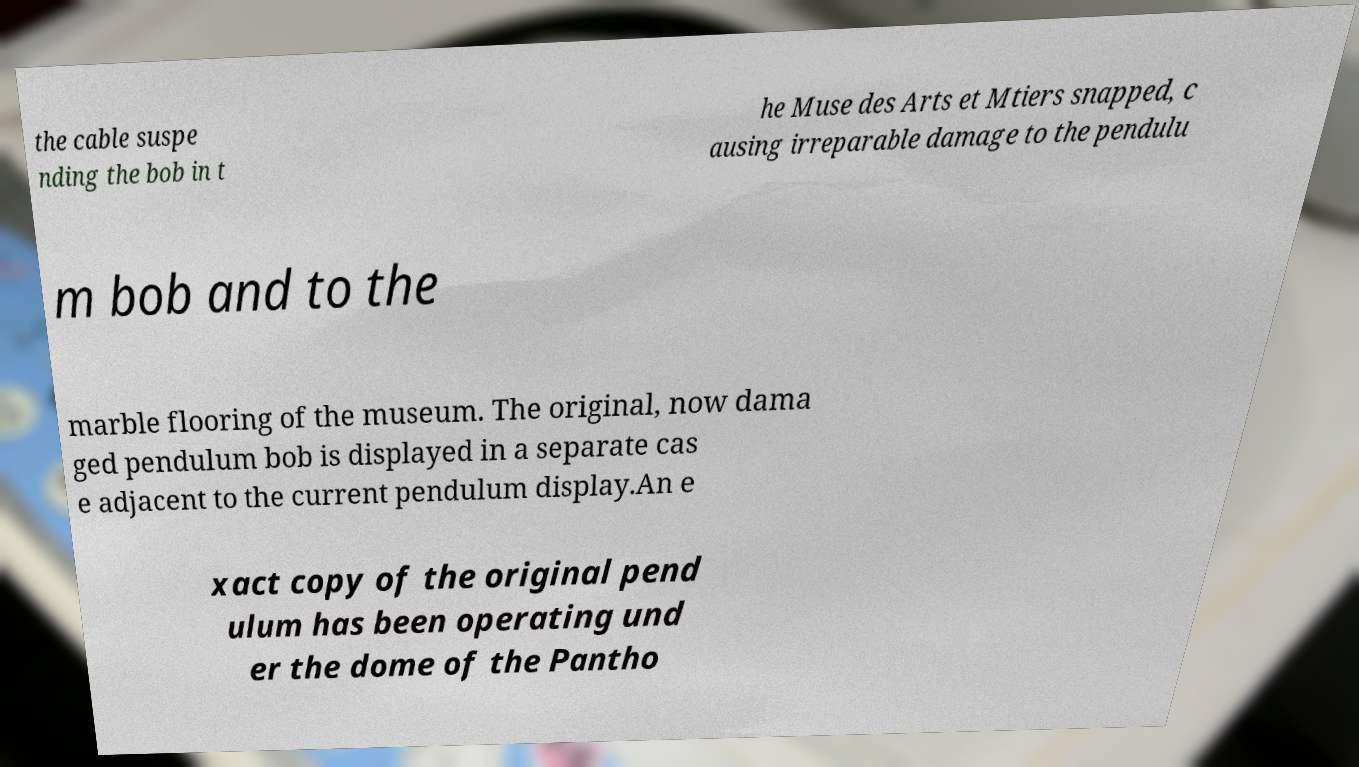Please read and relay the text visible in this image. What does it say? the cable suspe nding the bob in t he Muse des Arts et Mtiers snapped, c ausing irreparable damage to the pendulu m bob and to the marble flooring of the museum. The original, now dama ged pendulum bob is displayed in a separate cas e adjacent to the current pendulum display.An e xact copy of the original pend ulum has been operating und er the dome of the Pantho 